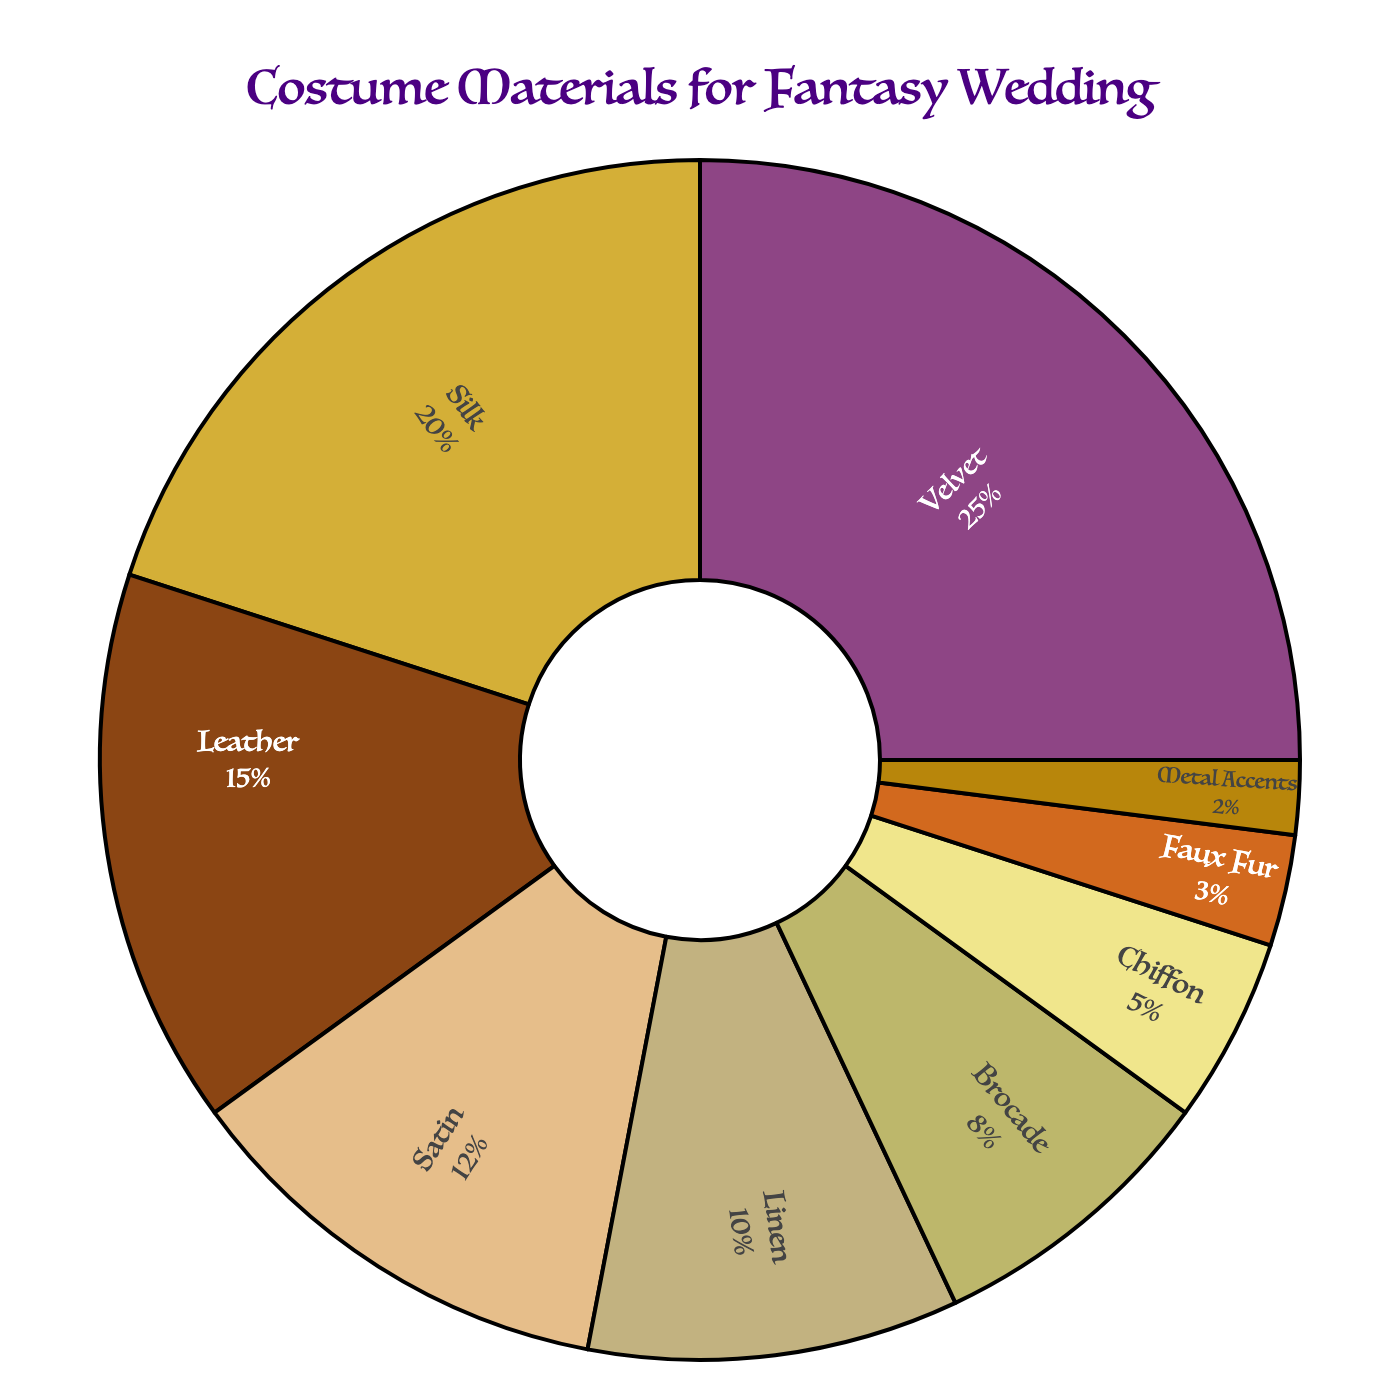Which material is used the most in wedding party attire? Look at the slice representing the largest percentage in the pie chart. Velvet has the largest slice at 25%.
Answer: Velvet Which materials collectively make up more than 50% of the attire? Adding up the largest percentages first: Velvet (25%) + Silk (20%) = 45%, and then add Leather (15%) to make 60%, which is more than 50%.
Answer: Velvet, Silk, Leather How much more percentage does Velvet have compared to Metal Accents? Subtract the percentage of Metal Accents from Velvet: 25% - 2% = 23%.
Answer: 23% Which two materials combined have the same percentage as Velvet? Find two materials whose percentages add up to Velvet's 25%. Silk (20%) + Chiffon (5%) = 25%.
Answer: Silk and Chiffon Rank the materials from most to least used in the wedding attire. Order the materials by their percentages from highest to lowest: Velvet (25%), Silk (20%), Leather (15%), Satin (12%), Linen (10%), Brocade (8%), Chiffon (5%), Faux Fur (3%), Metal Accents (2%).
Answer: Velvet, Silk, Leather, Satin, Linen, Brocade, Chiffon, Faux Fur, Metal Accents What is the average percentage of Silk, Satin, and Linen? Sum the percentages of Silk (20%), Satin (12%), and Linen (10%): 20% + 12% + 10% = 42%. Then divide by 3: 42% / 3 = 14%.
Answer: 14% Which material has a percentage that is one-fifth of Velvet's percentage? Calculate one-fifth of Velvet's percentage: 25% / 5 = 5%. The material with 5% is Chiffon.
Answer: Chiffon By how much does the combined percentage of the least two used materials differ from that of Satin? Combine the percentages of the least two used materials: Metal Accents (2%) + Faux Fur (3%) = 5%. Then subtract from Satin's percentage: 12% - 5% = 7%.
Answer: 7% Identify a material whose percentage is exactly double that of Brocade. Double Brocade's percentage: 8% * 2 = 16%. None of the materials exactly match 16%, so there is no material that fits the criteria.
Answer: None Which material is closer in usage percentage to Satin: Linen or Leather? Compare the differences: Satin (12%) - Linen (10%) = 2%, Satin (12%) - Leather (15%) = 3%. Linen's difference (2%) is smaller than Leather's (3%).
Answer: Linen 